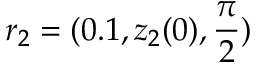Convert formula to latex. <formula><loc_0><loc_0><loc_500><loc_500>r _ { 2 } = ( 0 . 1 , z _ { 2 } ( 0 ) , \frac { \pi } { 2 } )</formula> 